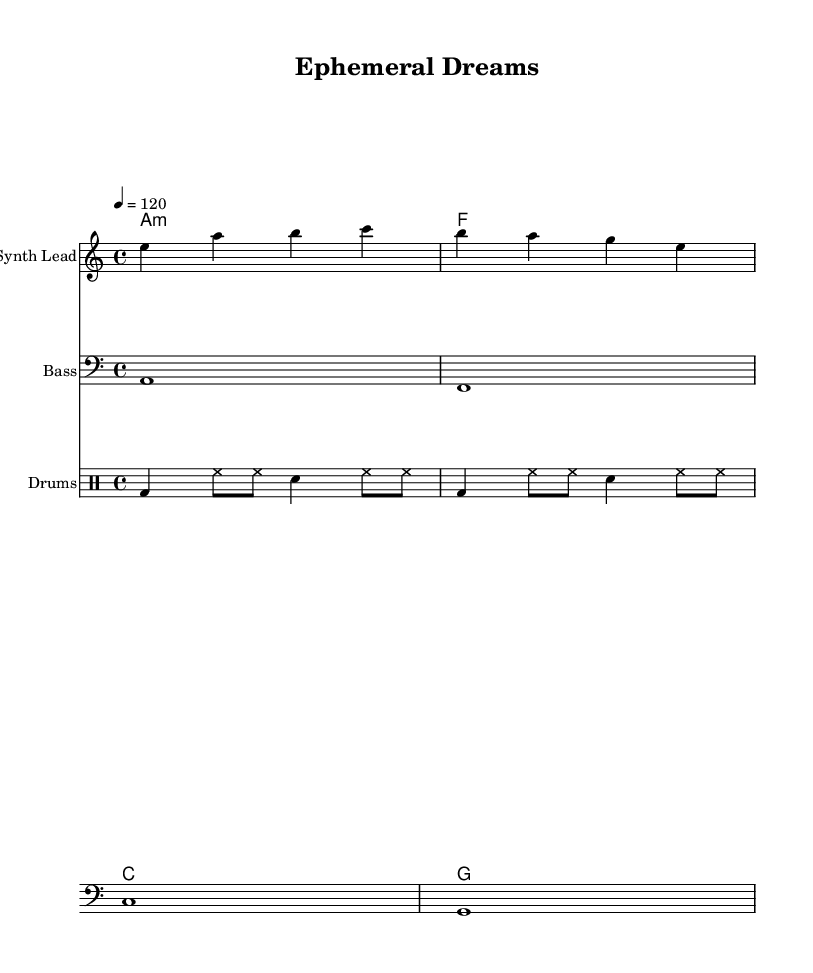What is the key signature of this music? The key signature is A minor, which is denoted by the absence of sharps or flats on the staff.
Answer: A minor What is the time signature of this music? The time signature is indicated as 4/4, meaning there are four beats per measure and the quarter note receives one beat.
Answer: 4/4 What is the tempo marking for this piece? The tempo marking indicates a speed of 120 beats per minute, which is indicated next to the tempo instruction in the score.
Answer: 120 How many measures are present in the melody? The melody contains four measures, which can be counted visually in the sheet music from the beginning to the end of the provided melodic line.
Answer: 4 What instruments are used in this score? The score includes a synth lead, bass, and drums as indicated by the instrument names above each staff.
Answer: Synth Lead, Bass, Drums Which chord is played in the first measure? The first measure contains an A minor chord, which is represented in the harmonies section at the beginning of the score.
Answer: A minor What type of music is this sheet likely representing? This is indicative of K-Pop music due to the format, instrumentation, and style, which often includes vibrant melodies and extensive use of synthesizers and rhythmic patterns.
Answer: K-Pop 